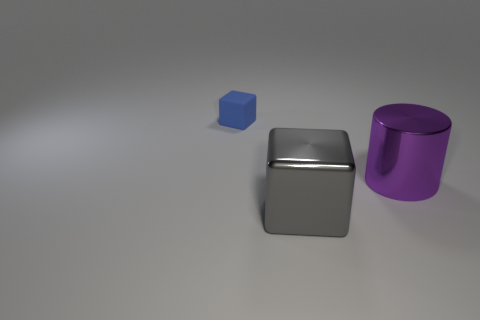Add 2 small blue things. How many objects exist? 5 Subtract all cubes. How many objects are left? 1 Subtract all blue blocks. How many blocks are left? 1 Subtract all green cylinders. Subtract all brown blocks. How many cylinders are left? 1 Subtract all gray blocks. How many brown cylinders are left? 0 Subtract all tiny red spheres. Subtract all small blue matte cubes. How many objects are left? 2 Add 3 purple metallic things. How many purple metallic things are left? 4 Add 3 gray matte cylinders. How many gray matte cylinders exist? 3 Subtract 1 gray cubes. How many objects are left? 2 